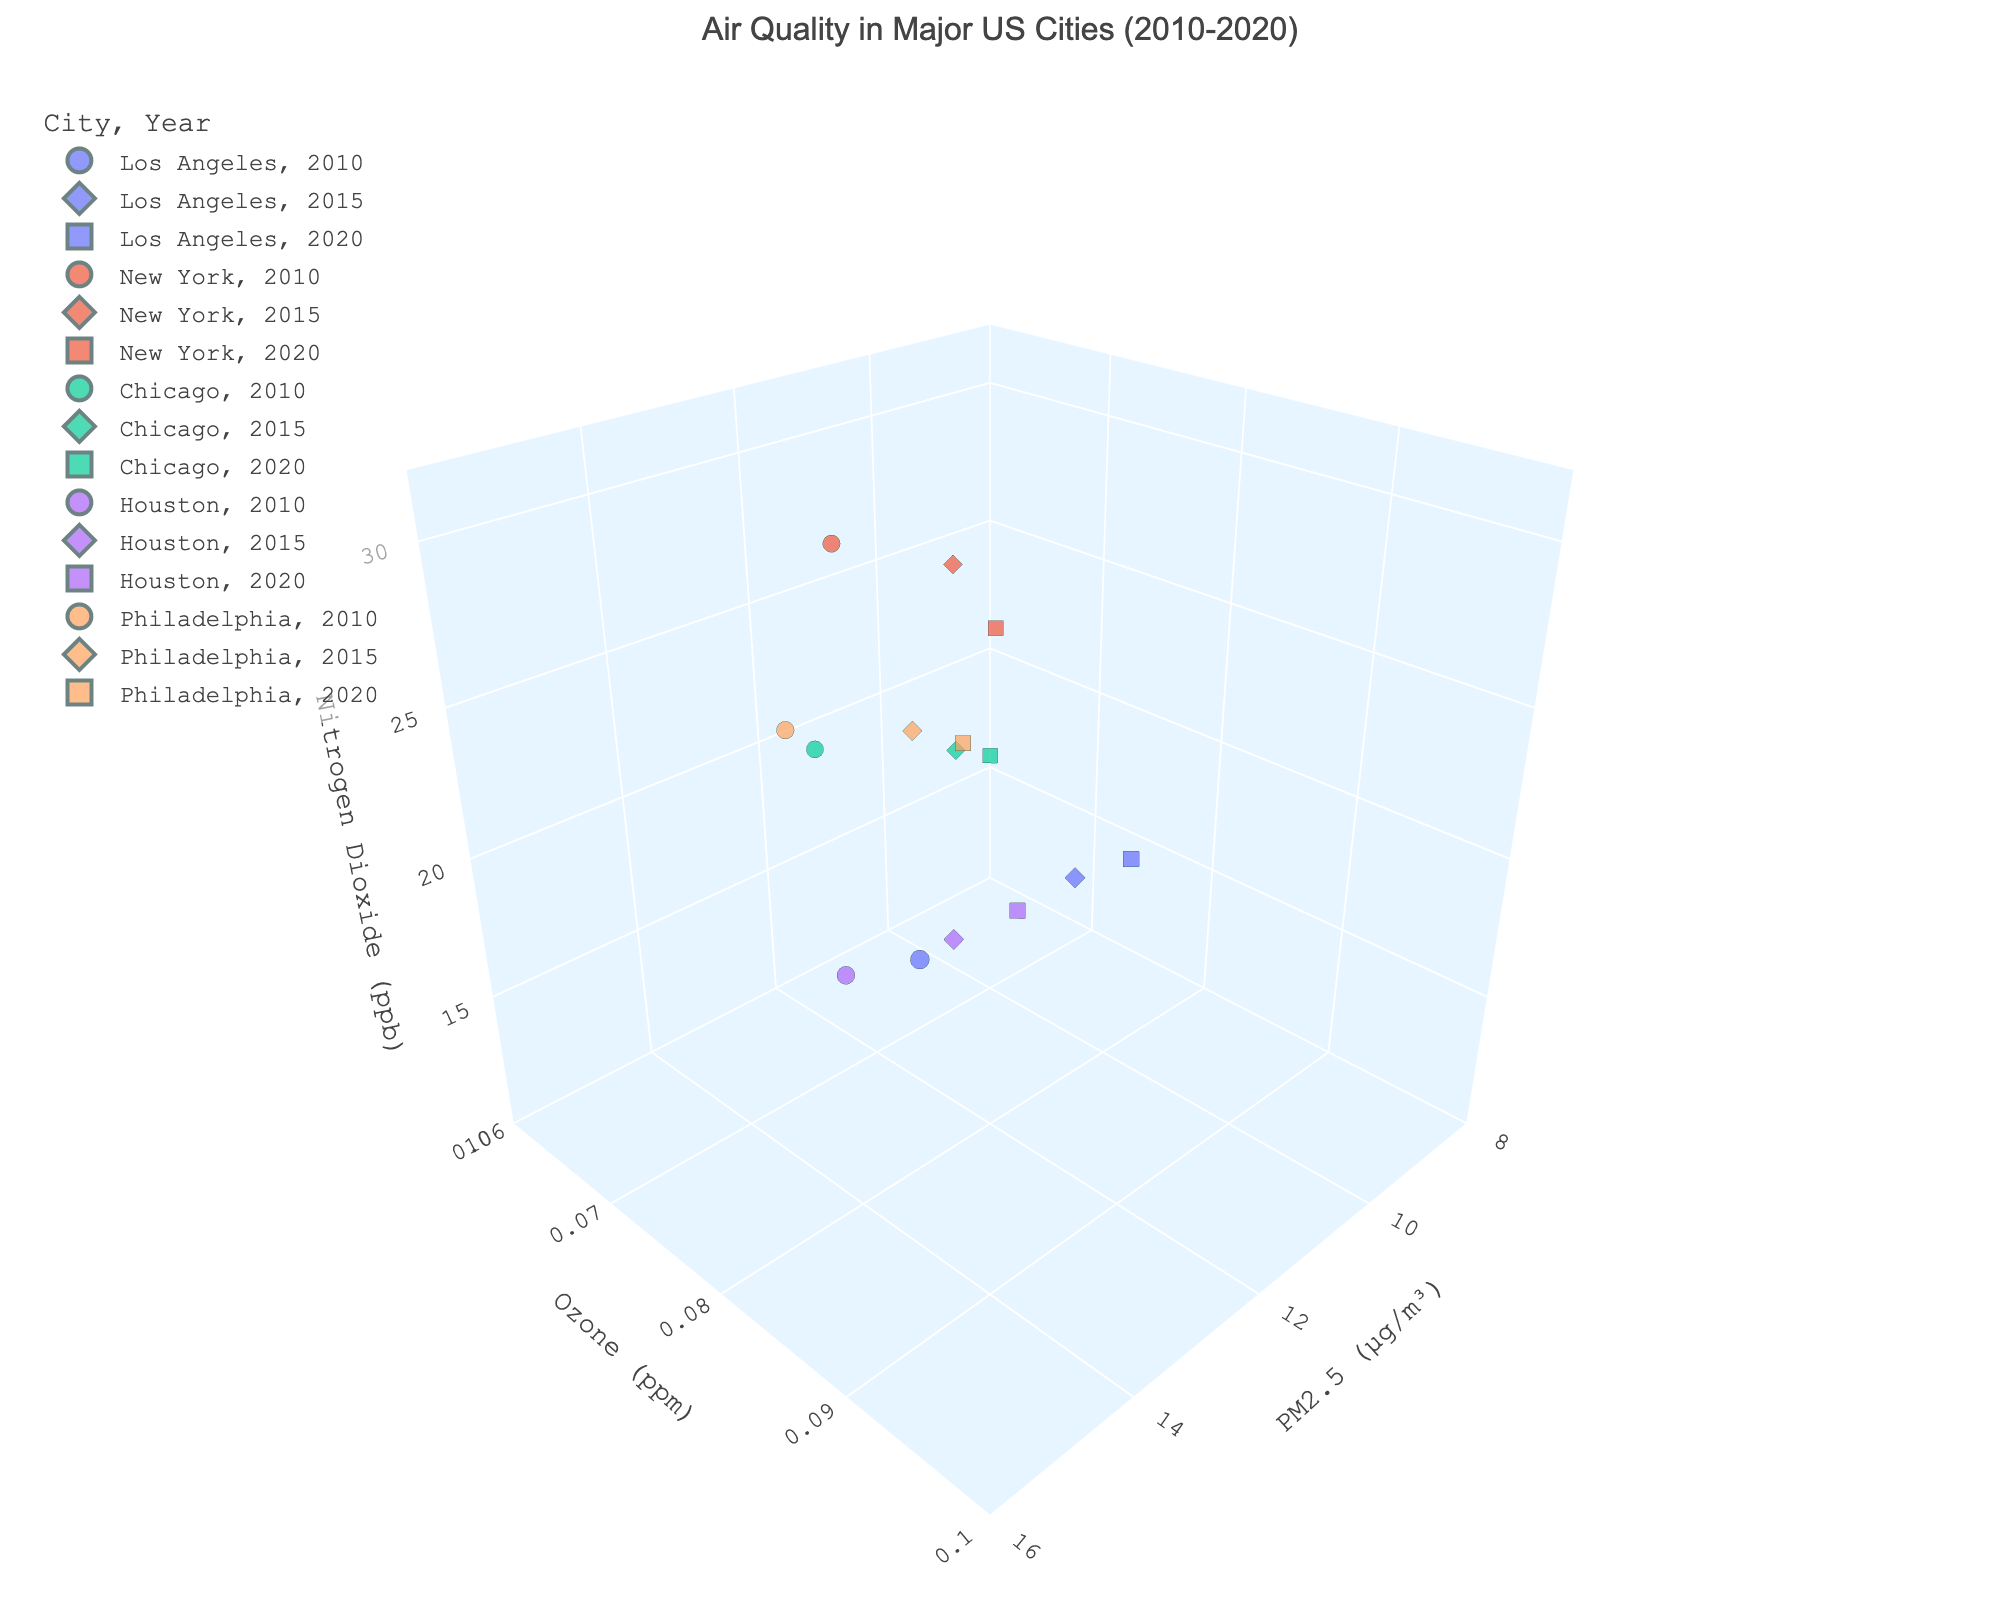What is the title of the plot? The title of the plot is displayed at the top of the figure.
Answer: Air Quality in Major US Cities (2010-2020) Which city has the highest PM2.5 levels in 2020? To determine this, look for the symbols marked for 2020 in the PM2.5 axis. Compare the PM2.5 values.
Answer: Los Angeles What is the average Nitrogen Dioxide level for New York in all years? Add the Nitrogen Dioxide values for New York (30.1 + 26.8 + 22.4), then divide by 3.
Answer: 26.43 Which year shows the greatest decrease in Ozone levels in Houston? Compare the changes in Ozone levels in Houston across the years: 2010 to 2015, and 2015 to 2020.
Answer: 2010 to 2015 How does PM2.5 in Chicago in 2010 compare to that in 2020? Locate Chicago’s data points for 2010 and 2020 and compare their PM2.5 values.
Answer: Higher in 2010 Which city has the lowest overall Ozone levels in 2020? Look at 2020 data points for the lowest Ozone values.
Answer: Chicago In which city and year is the highest Nitrogen Dioxide level observed? Find the highest Nitrogen Dioxide value across all data points and identify the corresponding city and year.
Answer: New York, 2010 Are there any cities where PM2.5 levels increased from 2010 to 2020? Examine the PM2.5 values for each city from 2010 to 2020 and check for any increases.
Answer: No What trend is observed in PM2.5 levels in Philadelphia from 2010 to 2020? Follow the PM2.5 values for Philadelphia over the years 2010, 2015, and 2020.
Answer: Decreasing Which city has the most data points on the plot? Count the number of data points for each city based on their color representation.
Answer: All cities have equal data points 